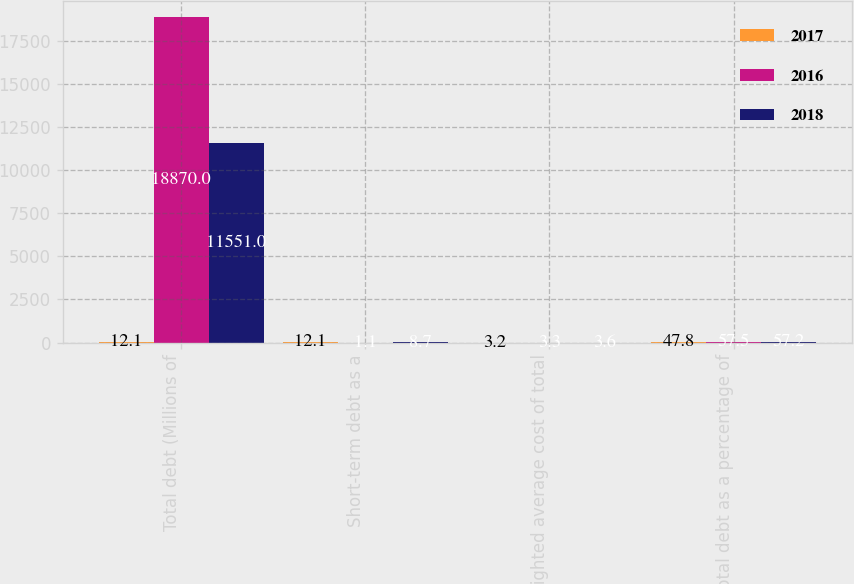Convert chart to OTSL. <chart><loc_0><loc_0><loc_500><loc_500><stacked_bar_chart><ecel><fcel>Total debt (Millions of<fcel>Short-term debt as a<fcel>Weighted average cost of total<fcel>Total debt as a percentage of<nl><fcel>2017<fcel>12.1<fcel>12.1<fcel>3.2<fcel>47.8<nl><fcel>2016<fcel>18870<fcel>1.1<fcel>3.3<fcel>57.5<nl><fcel>2018<fcel>11551<fcel>8.7<fcel>3.6<fcel>57.2<nl></chart> 